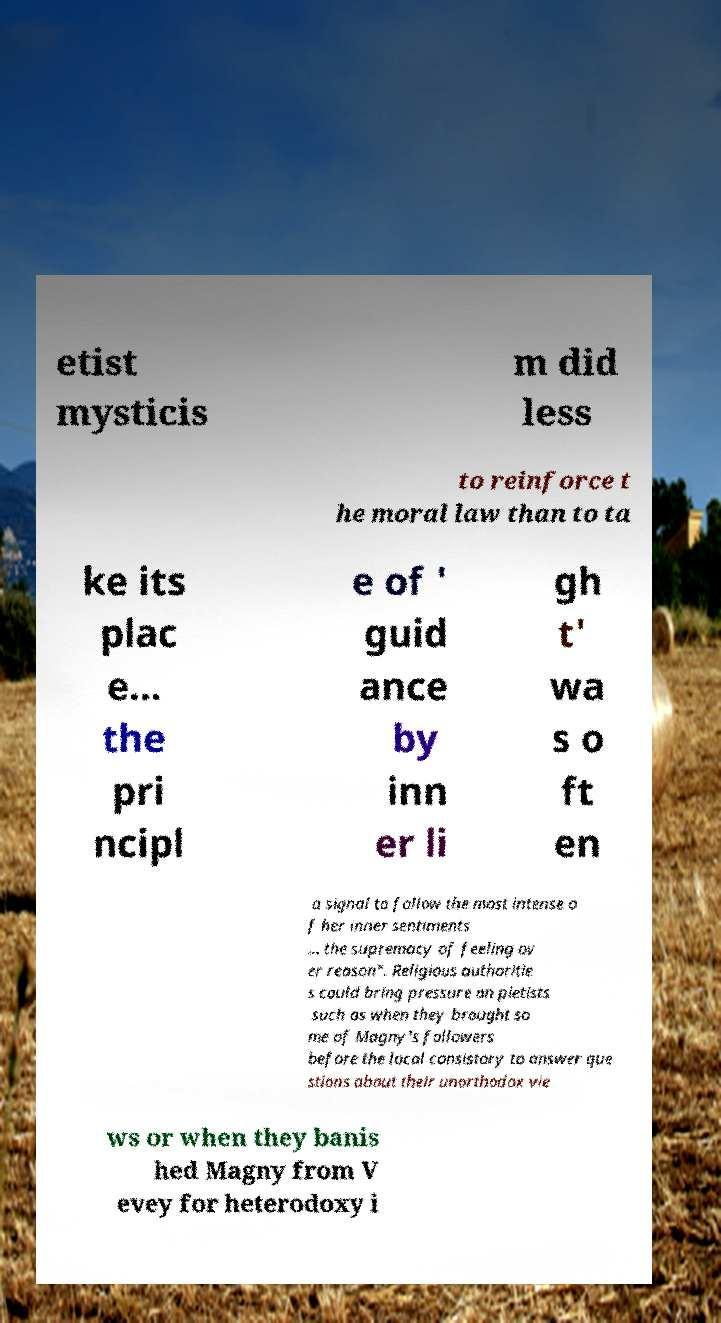Please identify and transcribe the text found in this image. etist mysticis m did less to reinforce t he moral law than to ta ke its plac e… the pri ncipl e of ' guid ance by inn er li gh t' wa s o ft en a signal to follow the most intense o f her inner sentiments … the supremacy of feeling ov er reason". Religious authoritie s could bring pressure on pietists such as when they brought so me of Magny's followers before the local consistory to answer que stions about their unorthodox vie ws or when they banis hed Magny from V evey for heterodoxy i 